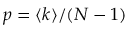Convert formula to latex. <formula><loc_0><loc_0><loc_500><loc_500>p = \langle k \rangle / ( N - 1 )</formula> 